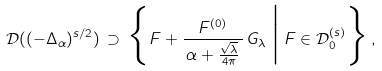Convert formula to latex. <formula><loc_0><loc_0><loc_500><loc_500>\mathcal { D } ( ( - \Delta _ { \alpha } ) ^ { s / 2 } ) \, \supset \, \Big \{ F + \frac { F ^ { ( 0 ) } } { \, \alpha + \frac { \sqrt { \lambda } } { 4 \pi } \, } \, G _ { \lambda } \, \Big | \, F \in \mathcal { D } _ { 0 } ^ { ( s ) } \Big \} \, ,</formula> 